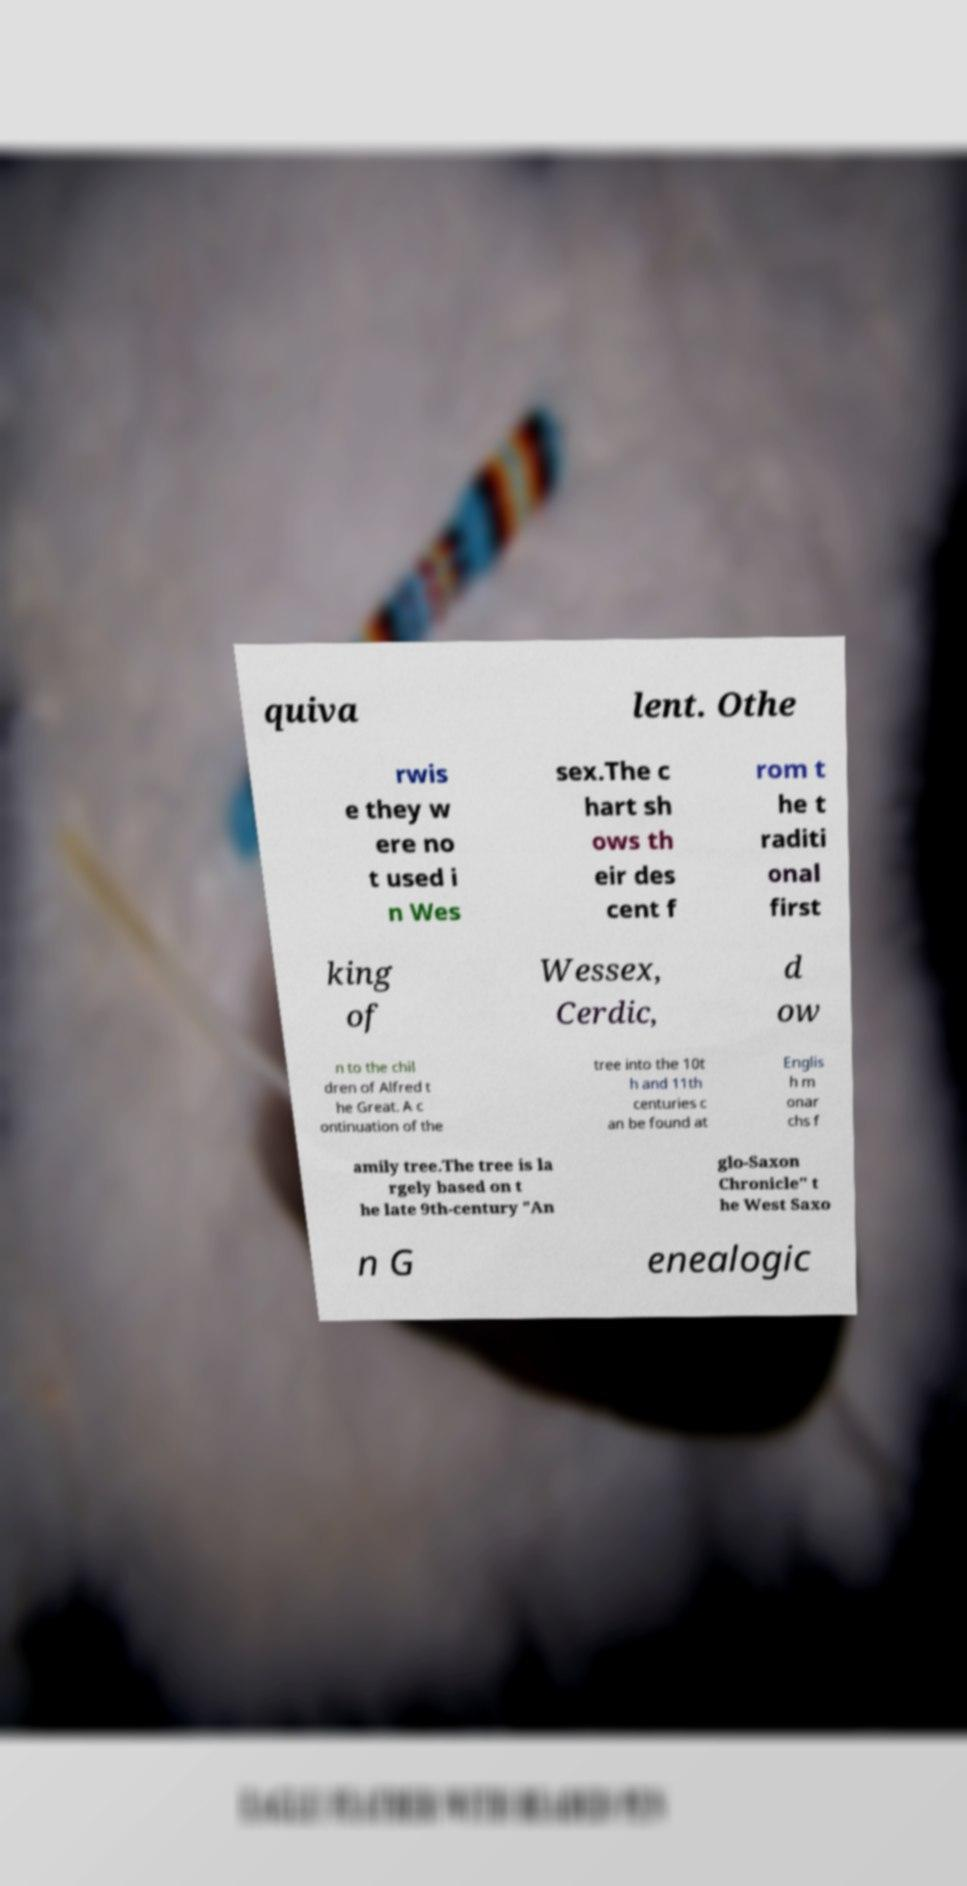What messages or text are displayed in this image? I need them in a readable, typed format. quiva lent. Othe rwis e they w ere no t used i n Wes sex.The c hart sh ows th eir des cent f rom t he t raditi onal first king of Wessex, Cerdic, d ow n to the chil dren of Alfred t he Great. A c ontinuation of the tree into the 10t h and 11th centuries c an be found at Englis h m onar chs f amily tree.The tree is la rgely based on t he late 9th-century "An glo-Saxon Chronicle" t he West Saxo n G enealogic 